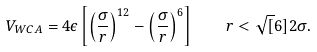Convert formula to latex. <formula><loc_0><loc_0><loc_500><loc_500>V _ { W C A } = 4 \epsilon \left [ \left ( \frac { \sigma } { r } \right ) ^ { 1 2 } - \left ( \frac { \sigma } { r } \right ) ^ { 6 } \right ] \quad r < \sqrt { [ } 6 ] { 2 \sigma } .</formula> 